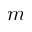Convert formula to latex. <formula><loc_0><loc_0><loc_500><loc_500>m</formula> 